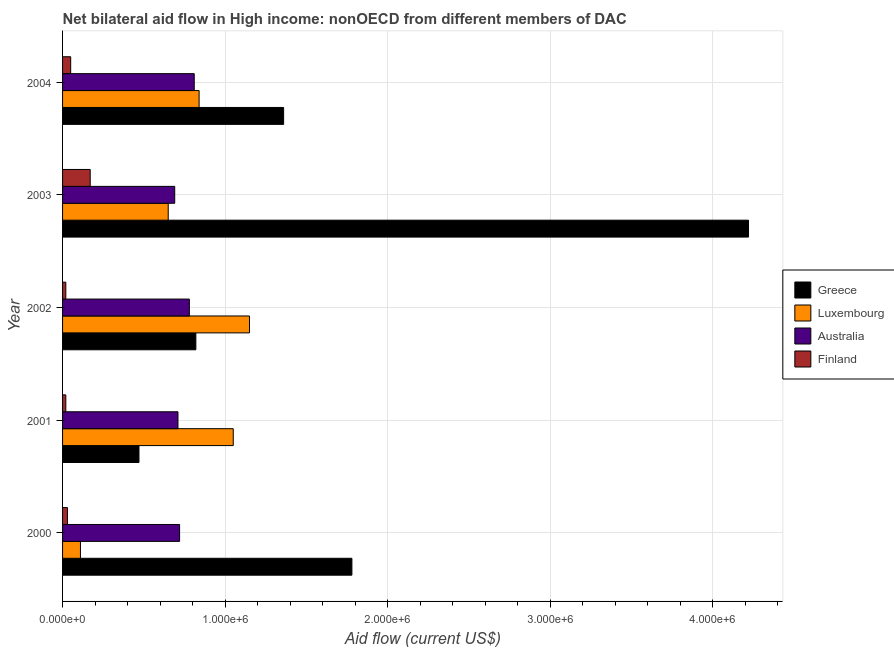Are the number of bars per tick equal to the number of legend labels?
Your response must be concise. Yes. Are the number of bars on each tick of the Y-axis equal?
Make the answer very short. Yes. How many bars are there on the 3rd tick from the top?
Provide a succinct answer. 4. How many bars are there on the 3rd tick from the bottom?
Your answer should be very brief. 4. What is the label of the 4th group of bars from the top?
Offer a very short reply. 2001. In how many cases, is the number of bars for a given year not equal to the number of legend labels?
Keep it short and to the point. 0. What is the amount of aid given by luxembourg in 2000?
Provide a succinct answer. 1.10e+05. Across all years, what is the maximum amount of aid given by luxembourg?
Offer a terse response. 1.15e+06. Across all years, what is the minimum amount of aid given by greece?
Your answer should be very brief. 4.70e+05. In which year was the amount of aid given by greece maximum?
Your response must be concise. 2003. What is the total amount of aid given by luxembourg in the graph?
Ensure brevity in your answer.  3.80e+06. What is the difference between the amount of aid given by australia in 2000 and that in 2002?
Give a very brief answer. -6.00e+04. What is the difference between the amount of aid given by finland in 2003 and the amount of aid given by australia in 2001?
Keep it short and to the point. -5.40e+05. What is the average amount of aid given by australia per year?
Your answer should be compact. 7.42e+05. In the year 2001, what is the difference between the amount of aid given by australia and amount of aid given by luxembourg?
Make the answer very short. -3.40e+05. In how many years, is the amount of aid given by australia greater than 4200000 US$?
Offer a very short reply. 0. What is the ratio of the amount of aid given by greece in 2003 to that in 2004?
Your response must be concise. 3.1. Is the amount of aid given by luxembourg in 2000 less than that in 2001?
Make the answer very short. Yes. Is the difference between the amount of aid given by finland in 2001 and 2004 greater than the difference between the amount of aid given by greece in 2001 and 2004?
Provide a short and direct response. Yes. What is the difference between the highest and the second highest amount of aid given by greece?
Provide a succinct answer. 2.44e+06. What is the difference between the highest and the lowest amount of aid given by greece?
Your response must be concise. 3.75e+06. In how many years, is the amount of aid given by finland greater than the average amount of aid given by finland taken over all years?
Keep it short and to the point. 1. Is it the case that in every year, the sum of the amount of aid given by australia and amount of aid given by greece is greater than the sum of amount of aid given by finland and amount of aid given by luxembourg?
Give a very brief answer. No. What does the 4th bar from the bottom in 2002 represents?
Offer a terse response. Finland. Is it the case that in every year, the sum of the amount of aid given by greece and amount of aid given by luxembourg is greater than the amount of aid given by australia?
Ensure brevity in your answer.  Yes. How many bars are there?
Provide a short and direct response. 20. Are all the bars in the graph horizontal?
Give a very brief answer. Yes. Are the values on the major ticks of X-axis written in scientific E-notation?
Offer a very short reply. Yes. Does the graph contain any zero values?
Ensure brevity in your answer.  No. Where does the legend appear in the graph?
Your answer should be compact. Center right. How many legend labels are there?
Your answer should be compact. 4. How are the legend labels stacked?
Provide a short and direct response. Vertical. What is the title of the graph?
Your response must be concise. Net bilateral aid flow in High income: nonOECD from different members of DAC. What is the label or title of the X-axis?
Provide a short and direct response. Aid flow (current US$). What is the label or title of the Y-axis?
Provide a short and direct response. Year. What is the Aid flow (current US$) of Greece in 2000?
Provide a short and direct response. 1.78e+06. What is the Aid flow (current US$) of Australia in 2000?
Ensure brevity in your answer.  7.20e+05. What is the Aid flow (current US$) in Finland in 2000?
Keep it short and to the point. 3.00e+04. What is the Aid flow (current US$) in Luxembourg in 2001?
Give a very brief answer. 1.05e+06. What is the Aid flow (current US$) in Australia in 2001?
Make the answer very short. 7.10e+05. What is the Aid flow (current US$) of Greece in 2002?
Make the answer very short. 8.20e+05. What is the Aid flow (current US$) in Luxembourg in 2002?
Give a very brief answer. 1.15e+06. What is the Aid flow (current US$) of Australia in 2002?
Offer a terse response. 7.80e+05. What is the Aid flow (current US$) of Greece in 2003?
Offer a terse response. 4.22e+06. What is the Aid flow (current US$) in Luxembourg in 2003?
Make the answer very short. 6.50e+05. What is the Aid flow (current US$) of Australia in 2003?
Give a very brief answer. 6.90e+05. What is the Aid flow (current US$) in Finland in 2003?
Keep it short and to the point. 1.70e+05. What is the Aid flow (current US$) of Greece in 2004?
Offer a very short reply. 1.36e+06. What is the Aid flow (current US$) of Luxembourg in 2004?
Give a very brief answer. 8.40e+05. What is the Aid flow (current US$) of Australia in 2004?
Your answer should be compact. 8.10e+05. Across all years, what is the maximum Aid flow (current US$) of Greece?
Offer a terse response. 4.22e+06. Across all years, what is the maximum Aid flow (current US$) in Luxembourg?
Give a very brief answer. 1.15e+06. Across all years, what is the maximum Aid flow (current US$) of Australia?
Your answer should be very brief. 8.10e+05. Across all years, what is the minimum Aid flow (current US$) of Greece?
Keep it short and to the point. 4.70e+05. Across all years, what is the minimum Aid flow (current US$) in Luxembourg?
Provide a succinct answer. 1.10e+05. Across all years, what is the minimum Aid flow (current US$) of Australia?
Keep it short and to the point. 6.90e+05. What is the total Aid flow (current US$) in Greece in the graph?
Your answer should be very brief. 8.65e+06. What is the total Aid flow (current US$) of Luxembourg in the graph?
Your answer should be very brief. 3.80e+06. What is the total Aid flow (current US$) of Australia in the graph?
Your answer should be very brief. 3.71e+06. What is the total Aid flow (current US$) in Finland in the graph?
Your answer should be very brief. 2.90e+05. What is the difference between the Aid flow (current US$) in Greece in 2000 and that in 2001?
Ensure brevity in your answer.  1.31e+06. What is the difference between the Aid flow (current US$) of Luxembourg in 2000 and that in 2001?
Offer a very short reply. -9.40e+05. What is the difference between the Aid flow (current US$) in Australia in 2000 and that in 2001?
Give a very brief answer. 10000. What is the difference between the Aid flow (current US$) of Finland in 2000 and that in 2001?
Your response must be concise. 10000. What is the difference between the Aid flow (current US$) in Greece in 2000 and that in 2002?
Your answer should be very brief. 9.60e+05. What is the difference between the Aid flow (current US$) in Luxembourg in 2000 and that in 2002?
Offer a very short reply. -1.04e+06. What is the difference between the Aid flow (current US$) of Finland in 2000 and that in 2002?
Provide a short and direct response. 10000. What is the difference between the Aid flow (current US$) of Greece in 2000 and that in 2003?
Your answer should be compact. -2.44e+06. What is the difference between the Aid flow (current US$) of Luxembourg in 2000 and that in 2003?
Provide a short and direct response. -5.40e+05. What is the difference between the Aid flow (current US$) of Greece in 2000 and that in 2004?
Give a very brief answer. 4.20e+05. What is the difference between the Aid flow (current US$) in Luxembourg in 2000 and that in 2004?
Keep it short and to the point. -7.30e+05. What is the difference between the Aid flow (current US$) of Australia in 2000 and that in 2004?
Your response must be concise. -9.00e+04. What is the difference between the Aid flow (current US$) of Finland in 2000 and that in 2004?
Keep it short and to the point. -2.00e+04. What is the difference between the Aid flow (current US$) in Greece in 2001 and that in 2002?
Offer a terse response. -3.50e+05. What is the difference between the Aid flow (current US$) of Luxembourg in 2001 and that in 2002?
Make the answer very short. -1.00e+05. What is the difference between the Aid flow (current US$) in Australia in 2001 and that in 2002?
Offer a terse response. -7.00e+04. What is the difference between the Aid flow (current US$) of Finland in 2001 and that in 2002?
Provide a succinct answer. 0. What is the difference between the Aid flow (current US$) in Greece in 2001 and that in 2003?
Ensure brevity in your answer.  -3.75e+06. What is the difference between the Aid flow (current US$) in Luxembourg in 2001 and that in 2003?
Make the answer very short. 4.00e+05. What is the difference between the Aid flow (current US$) of Australia in 2001 and that in 2003?
Your answer should be very brief. 2.00e+04. What is the difference between the Aid flow (current US$) in Finland in 2001 and that in 2003?
Offer a terse response. -1.50e+05. What is the difference between the Aid flow (current US$) in Greece in 2001 and that in 2004?
Your answer should be compact. -8.90e+05. What is the difference between the Aid flow (current US$) of Luxembourg in 2001 and that in 2004?
Give a very brief answer. 2.10e+05. What is the difference between the Aid flow (current US$) in Australia in 2001 and that in 2004?
Provide a succinct answer. -1.00e+05. What is the difference between the Aid flow (current US$) in Finland in 2001 and that in 2004?
Give a very brief answer. -3.00e+04. What is the difference between the Aid flow (current US$) of Greece in 2002 and that in 2003?
Offer a terse response. -3.40e+06. What is the difference between the Aid flow (current US$) in Luxembourg in 2002 and that in 2003?
Your answer should be very brief. 5.00e+05. What is the difference between the Aid flow (current US$) of Finland in 2002 and that in 2003?
Keep it short and to the point. -1.50e+05. What is the difference between the Aid flow (current US$) of Greece in 2002 and that in 2004?
Ensure brevity in your answer.  -5.40e+05. What is the difference between the Aid flow (current US$) in Luxembourg in 2002 and that in 2004?
Make the answer very short. 3.10e+05. What is the difference between the Aid flow (current US$) in Australia in 2002 and that in 2004?
Keep it short and to the point. -3.00e+04. What is the difference between the Aid flow (current US$) in Finland in 2002 and that in 2004?
Your response must be concise. -3.00e+04. What is the difference between the Aid flow (current US$) in Greece in 2003 and that in 2004?
Give a very brief answer. 2.86e+06. What is the difference between the Aid flow (current US$) in Australia in 2003 and that in 2004?
Give a very brief answer. -1.20e+05. What is the difference between the Aid flow (current US$) in Finland in 2003 and that in 2004?
Give a very brief answer. 1.20e+05. What is the difference between the Aid flow (current US$) in Greece in 2000 and the Aid flow (current US$) in Luxembourg in 2001?
Provide a succinct answer. 7.30e+05. What is the difference between the Aid flow (current US$) in Greece in 2000 and the Aid flow (current US$) in Australia in 2001?
Keep it short and to the point. 1.07e+06. What is the difference between the Aid flow (current US$) of Greece in 2000 and the Aid flow (current US$) of Finland in 2001?
Provide a succinct answer. 1.76e+06. What is the difference between the Aid flow (current US$) in Luxembourg in 2000 and the Aid flow (current US$) in Australia in 2001?
Provide a succinct answer. -6.00e+05. What is the difference between the Aid flow (current US$) of Luxembourg in 2000 and the Aid flow (current US$) of Finland in 2001?
Keep it short and to the point. 9.00e+04. What is the difference between the Aid flow (current US$) of Australia in 2000 and the Aid flow (current US$) of Finland in 2001?
Your response must be concise. 7.00e+05. What is the difference between the Aid flow (current US$) in Greece in 2000 and the Aid flow (current US$) in Luxembourg in 2002?
Ensure brevity in your answer.  6.30e+05. What is the difference between the Aid flow (current US$) in Greece in 2000 and the Aid flow (current US$) in Australia in 2002?
Ensure brevity in your answer.  1.00e+06. What is the difference between the Aid flow (current US$) in Greece in 2000 and the Aid flow (current US$) in Finland in 2002?
Offer a terse response. 1.76e+06. What is the difference between the Aid flow (current US$) in Luxembourg in 2000 and the Aid flow (current US$) in Australia in 2002?
Keep it short and to the point. -6.70e+05. What is the difference between the Aid flow (current US$) of Australia in 2000 and the Aid flow (current US$) of Finland in 2002?
Your answer should be very brief. 7.00e+05. What is the difference between the Aid flow (current US$) in Greece in 2000 and the Aid flow (current US$) in Luxembourg in 2003?
Your response must be concise. 1.13e+06. What is the difference between the Aid flow (current US$) in Greece in 2000 and the Aid flow (current US$) in Australia in 2003?
Give a very brief answer. 1.09e+06. What is the difference between the Aid flow (current US$) in Greece in 2000 and the Aid flow (current US$) in Finland in 2003?
Keep it short and to the point. 1.61e+06. What is the difference between the Aid flow (current US$) in Luxembourg in 2000 and the Aid flow (current US$) in Australia in 2003?
Provide a short and direct response. -5.80e+05. What is the difference between the Aid flow (current US$) in Australia in 2000 and the Aid flow (current US$) in Finland in 2003?
Make the answer very short. 5.50e+05. What is the difference between the Aid flow (current US$) in Greece in 2000 and the Aid flow (current US$) in Luxembourg in 2004?
Provide a succinct answer. 9.40e+05. What is the difference between the Aid flow (current US$) in Greece in 2000 and the Aid flow (current US$) in Australia in 2004?
Provide a short and direct response. 9.70e+05. What is the difference between the Aid flow (current US$) of Greece in 2000 and the Aid flow (current US$) of Finland in 2004?
Provide a succinct answer. 1.73e+06. What is the difference between the Aid flow (current US$) in Luxembourg in 2000 and the Aid flow (current US$) in Australia in 2004?
Offer a terse response. -7.00e+05. What is the difference between the Aid flow (current US$) of Australia in 2000 and the Aid flow (current US$) of Finland in 2004?
Offer a very short reply. 6.70e+05. What is the difference between the Aid flow (current US$) in Greece in 2001 and the Aid flow (current US$) in Luxembourg in 2002?
Provide a short and direct response. -6.80e+05. What is the difference between the Aid flow (current US$) in Greece in 2001 and the Aid flow (current US$) in Australia in 2002?
Your response must be concise. -3.10e+05. What is the difference between the Aid flow (current US$) of Greece in 2001 and the Aid flow (current US$) of Finland in 2002?
Provide a succinct answer. 4.50e+05. What is the difference between the Aid flow (current US$) of Luxembourg in 2001 and the Aid flow (current US$) of Finland in 2002?
Your answer should be compact. 1.03e+06. What is the difference between the Aid flow (current US$) of Australia in 2001 and the Aid flow (current US$) of Finland in 2002?
Offer a terse response. 6.90e+05. What is the difference between the Aid flow (current US$) of Greece in 2001 and the Aid flow (current US$) of Luxembourg in 2003?
Make the answer very short. -1.80e+05. What is the difference between the Aid flow (current US$) in Greece in 2001 and the Aid flow (current US$) in Australia in 2003?
Offer a very short reply. -2.20e+05. What is the difference between the Aid flow (current US$) of Greece in 2001 and the Aid flow (current US$) of Finland in 2003?
Make the answer very short. 3.00e+05. What is the difference between the Aid flow (current US$) of Luxembourg in 2001 and the Aid flow (current US$) of Finland in 2003?
Your answer should be compact. 8.80e+05. What is the difference between the Aid flow (current US$) of Australia in 2001 and the Aid flow (current US$) of Finland in 2003?
Provide a succinct answer. 5.40e+05. What is the difference between the Aid flow (current US$) in Greece in 2001 and the Aid flow (current US$) in Luxembourg in 2004?
Ensure brevity in your answer.  -3.70e+05. What is the difference between the Aid flow (current US$) of Greece in 2001 and the Aid flow (current US$) of Australia in 2004?
Your answer should be very brief. -3.40e+05. What is the difference between the Aid flow (current US$) of Greece in 2002 and the Aid flow (current US$) of Australia in 2003?
Offer a terse response. 1.30e+05. What is the difference between the Aid flow (current US$) in Greece in 2002 and the Aid flow (current US$) in Finland in 2003?
Your answer should be compact. 6.50e+05. What is the difference between the Aid flow (current US$) of Luxembourg in 2002 and the Aid flow (current US$) of Australia in 2003?
Make the answer very short. 4.60e+05. What is the difference between the Aid flow (current US$) in Luxembourg in 2002 and the Aid flow (current US$) in Finland in 2003?
Your answer should be compact. 9.80e+05. What is the difference between the Aid flow (current US$) in Greece in 2002 and the Aid flow (current US$) in Finland in 2004?
Offer a very short reply. 7.70e+05. What is the difference between the Aid flow (current US$) of Luxembourg in 2002 and the Aid flow (current US$) of Australia in 2004?
Offer a terse response. 3.40e+05. What is the difference between the Aid flow (current US$) of Luxembourg in 2002 and the Aid flow (current US$) of Finland in 2004?
Your answer should be compact. 1.10e+06. What is the difference between the Aid flow (current US$) of Australia in 2002 and the Aid flow (current US$) of Finland in 2004?
Provide a short and direct response. 7.30e+05. What is the difference between the Aid flow (current US$) of Greece in 2003 and the Aid flow (current US$) of Luxembourg in 2004?
Provide a short and direct response. 3.38e+06. What is the difference between the Aid flow (current US$) of Greece in 2003 and the Aid flow (current US$) of Australia in 2004?
Provide a succinct answer. 3.41e+06. What is the difference between the Aid flow (current US$) in Greece in 2003 and the Aid flow (current US$) in Finland in 2004?
Make the answer very short. 4.17e+06. What is the difference between the Aid flow (current US$) of Luxembourg in 2003 and the Aid flow (current US$) of Finland in 2004?
Your answer should be compact. 6.00e+05. What is the difference between the Aid flow (current US$) in Australia in 2003 and the Aid flow (current US$) in Finland in 2004?
Keep it short and to the point. 6.40e+05. What is the average Aid flow (current US$) of Greece per year?
Make the answer very short. 1.73e+06. What is the average Aid flow (current US$) of Luxembourg per year?
Give a very brief answer. 7.60e+05. What is the average Aid flow (current US$) in Australia per year?
Give a very brief answer. 7.42e+05. What is the average Aid flow (current US$) of Finland per year?
Provide a succinct answer. 5.80e+04. In the year 2000, what is the difference between the Aid flow (current US$) in Greece and Aid flow (current US$) in Luxembourg?
Keep it short and to the point. 1.67e+06. In the year 2000, what is the difference between the Aid flow (current US$) of Greece and Aid flow (current US$) of Australia?
Provide a short and direct response. 1.06e+06. In the year 2000, what is the difference between the Aid flow (current US$) in Greece and Aid flow (current US$) in Finland?
Give a very brief answer. 1.75e+06. In the year 2000, what is the difference between the Aid flow (current US$) of Luxembourg and Aid flow (current US$) of Australia?
Give a very brief answer. -6.10e+05. In the year 2000, what is the difference between the Aid flow (current US$) of Australia and Aid flow (current US$) of Finland?
Your answer should be very brief. 6.90e+05. In the year 2001, what is the difference between the Aid flow (current US$) in Greece and Aid flow (current US$) in Luxembourg?
Give a very brief answer. -5.80e+05. In the year 2001, what is the difference between the Aid flow (current US$) in Luxembourg and Aid flow (current US$) in Australia?
Provide a short and direct response. 3.40e+05. In the year 2001, what is the difference between the Aid flow (current US$) of Luxembourg and Aid flow (current US$) of Finland?
Give a very brief answer. 1.03e+06. In the year 2001, what is the difference between the Aid flow (current US$) in Australia and Aid flow (current US$) in Finland?
Ensure brevity in your answer.  6.90e+05. In the year 2002, what is the difference between the Aid flow (current US$) in Greece and Aid flow (current US$) in Luxembourg?
Make the answer very short. -3.30e+05. In the year 2002, what is the difference between the Aid flow (current US$) of Greece and Aid flow (current US$) of Finland?
Offer a very short reply. 8.00e+05. In the year 2002, what is the difference between the Aid flow (current US$) in Luxembourg and Aid flow (current US$) in Finland?
Make the answer very short. 1.13e+06. In the year 2002, what is the difference between the Aid flow (current US$) in Australia and Aid flow (current US$) in Finland?
Give a very brief answer. 7.60e+05. In the year 2003, what is the difference between the Aid flow (current US$) in Greece and Aid flow (current US$) in Luxembourg?
Your response must be concise. 3.57e+06. In the year 2003, what is the difference between the Aid flow (current US$) of Greece and Aid flow (current US$) of Australia?
Give a very brief answer. 3.53e+06. In the year 2003, what is the difference between the Aid flow (current US$) of Greece and Aid flow (current US$) of Finland?
Keep it short and to the point. 4.05e+06. In the year 2003, what is the difference between the Aid flow (current US$) in Luxembourg and Aid flow (current US$) in Australia?
Your response must be concise. -4.00e+04. In the year 2003, what is the difference between the Aid flow (current US$) of Australia and Aid flow (current US$) of Finland?
Your answer should be compact. 5.20e+05. In the year 2004, what is the difference between the Aid flow (current US$) of Greece and Aid flow (current US$) of Luxembourg?
Make the answer very short. 5.20e+05. In the year 2004, what is the difference between the Aid flow (current US$) of Greece and Aid flow (current US$) of Australia?
Keep it short and to the point. 5.50e+05. In the year 2004, what is the difference between the Aid flow (current US$) in Greece and Aid flow (current US$) in Finland?
Your response must be concise. 1.31e+06. In the year 2004, what is the difference between the Aid flow (current US$) in Luxembourg and Aid flow (current US$) in Finland?
Offer a terse response. 7.90e+05. In the year 2004, what is the difference between the Aid flow (current US$) in Australia and Aid flow (current US$) in Finland?
Provide a succinct answer. 7.60e+05. What is the ratio of the Aid flow (current US$) in Greece in 2000 to that in 2001?
Provide a short and direct response. 3.79. What is the ratio of the Aid flow (current US$) of Luxembourg in 2000 to that in 2001?
Your response must be concise. 0.1. What is the ratio of the Aid flow (current US$) of Australia in 2000 to that in 2001?
Offer a terse response. 1.01. What is the ratio of the Aid flow (current US$) in Finland in 2000 to that in 2001?
Your answer should be very brief. 1.5. What is the ratio of the Aid flow (current US$) of Greece in 2000 to that in 2002?
Keep it short and to the point. 2.17. What is the ratio of the Aid flow (current US$) in Luxembourg in 2000 to that in 2002?
Ensure brevity in your answer.  0.1. What is the ratio of the Aid flow (current US$) of Australia in 2000 to that in 2002?
Your answer should be very brief. 0.92. What is the ratio of the Aid flow (current US$) of Greece in 2000 to that in 2003?
Make the answer very short. 0.42. What is the ratio of the Aid flow (current US$) of Luxembourg in 2000 to that in 2003?
Make the answer very short. 0.17. What is the ratio of the Aid flow (current US$) in Australia in 2000 to that in 2003?
Provide a succinct answer. 1.04. What is the ratio of the Aid flow (current US$) in Finland in 2000 to that in 2003?
Ensure brevity in your answer.  0.18. What is the ratio of the Aid flow (current US$) in Greece in 2000 to that in 2004?
Keep it short and to the point. 1.31. What is the ratio of the Aid flow (current US$) in Luxembourg in 2000 to that in 2004?
Your response must be concise. 0.13. What is the ratio of the Aid flow (current US$) in Finland in 2000 to that in 2004?
Provide a succinct answer. 0.6. What is the ratio of the Aid flow (current US$) in Greece in 2001 to that in 2002?
Provide a succinct answer. 0.57. What is the ratio of the Aid flow (current US$) in Australia in 2001 to that in 2002?
Offer a terse response. 0.91. What is the ratio of the Aid flow (current US$) in Finland in 2001 to that in 2002?
Your answer should be very brief. 1. What is the ratio of the Aid flow (current US$) in Greece in 2001 to that in 2003?
Keep it short and to the point. 0.11. What is the ratio of the Aid flow (current US$) of Luxembourg in 2001 to that in 2003?
Your response must be concise. 1.62. What is the ratio of the Aid flow (current US$) in Australia in 2001 to that in 2003?
Keep it short and to the point. 1.03. What is the ratio of the Aid flow (current US$) in Finland in 2001 to that in 2003?
Offer a very short reply. 0.12. What is the ratio of the Aid flow (current US$) of Greece in 2001 to that in 2004?
Provide a short and direct response. 0.35. What is the ratio of the Aid flow (current US$) in Australia in 2001 to that in 2004?
Offer a terse response. 0.88. What is the ratio of the Aid flow (current US$) of Greece in 2002 to that in 2003?
Make the answer very short. 0.19. What is the ratio of the Aid flow (current US$) in Luxembourg in 2002 to that in 2003?
Ensure brevity in your answer.  1.77. What is the ratio of the Aid flow (current US$) of Australia in 2002 to that in 2003?
Offer a very short reply. 1.13. What is the ratio of the Aid flow (current US$) in Finland in 2002 to that in 2003?
Keep it short and to the point. 0.12. What is the ratio of the Aid flow (current US$) of Greece in 2002 to that in 2004?
Offer a terse response. 0.6. What is the ratio of the Aid flow (current US$) in Luxembourg in 2002 to that in 2004?
Keep it short and to the point. 1.37. What is the ratio of the Aid flow (current US$) of Australia in 2002 to that in 2004?
Ensure brevity in your answer.  0.96. What is the ratio of the Aid flow (current US$) of Greece in 2003 to that in 2004?
Your answer should be compact. 3.1. What is the ratio of the Aid flow (current US$) in Luxembourg in 2003 to that in 2004?
Your answer should be compact. 0.77. What is the ratio of the Aid flow (current US$) of Australia in 2003 to that in 2004?
Your answer should be compact. 0.85. What is the difference between the highest and the second highest Aid flow (current US$) of Greece?
Ensure brevity in your answer.  2.44e+06. What is the difference between the highest and the second highest Aid flow (current US$) of Luxembourg?
Offer a terse response. 1.00e+05. What is the difference between the highest and the lowest Aid flow (current US$) of Greece?
Make the answer very short. 3.75e+06. What is the difference between the highest and the lowest Aid flow (current US$) of Luxembourg?
Provide a succinct answer. 1.04e+06. What is the difference between the highest and the lowest Aid flow (current US$) in Finland?
Keep it short and to the point. 1.50e+05. 